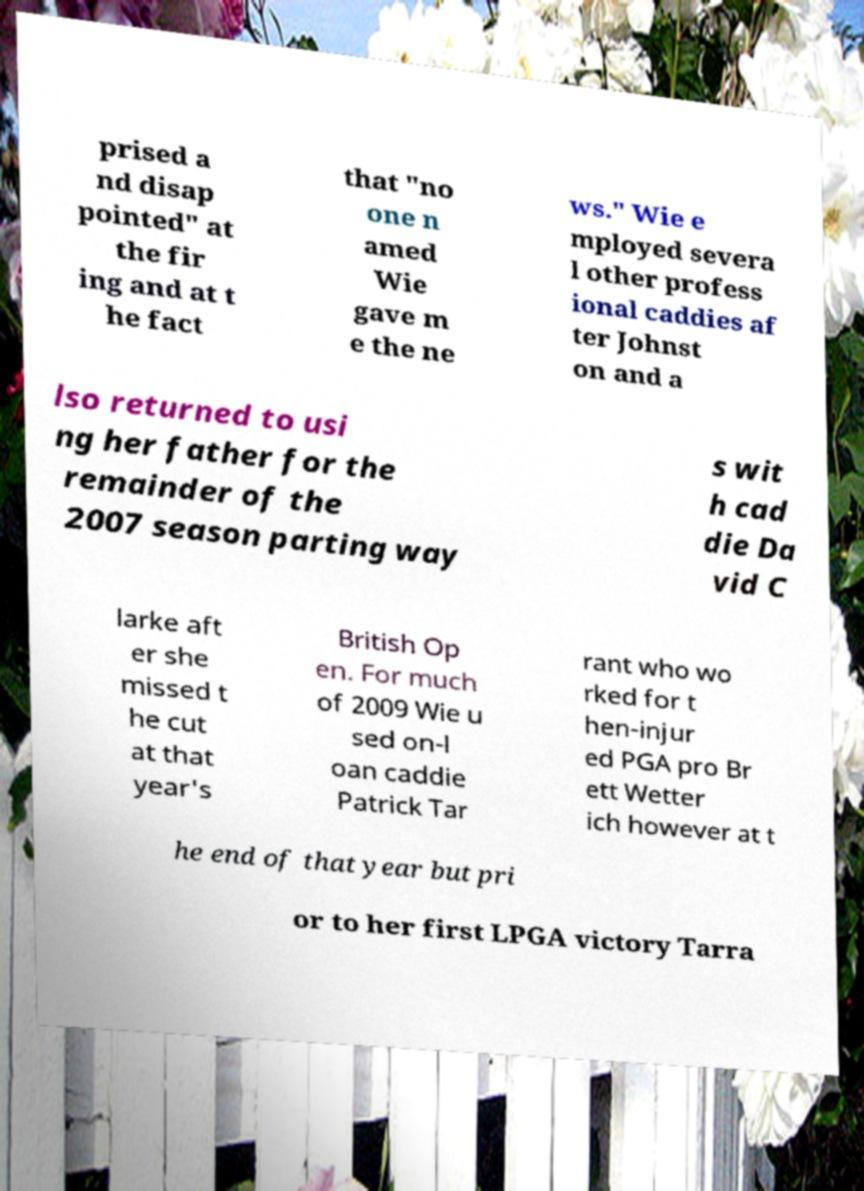Please read and relay the text visible in this image. What does it say? prised a nd disap pointed" at the fir ing and at t he fact that "no one n amed Wie gave m e the ne ws." Wie e mployed severa l other profess ional caddies af ter Johnst on and a lso returned to usi ng her father for the remainder of the 2007 season parting way s wit h cad die Da vid C larke aft er she missed t he cut at that year's British Op en. For much of 2009 Wie u sed on-l oan caddie Patrick Tar rant who wo rked for t hen-injur ed PGA pro Br ett Wetter ich however at t he end of that year but pri or to her first LPGA victory Tarra 